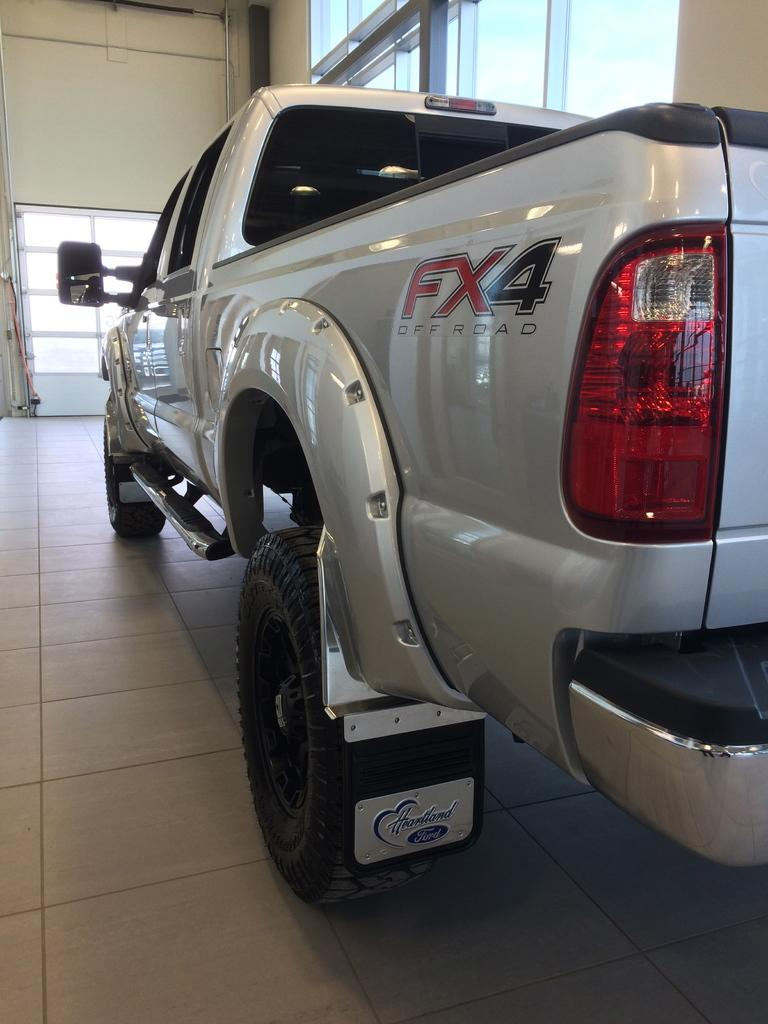What type of object is the main subject in the image? There is a vehicle in the image. What color is the vehicle? The vehicle is white in color. Is there any text or writing on the vehicle? Yes, there is writing on the vehicle. What can be seen on the floor in the image? The floor is visible in the image. What is visible in the background of the image? There is a wall and windows in the background of the image. What flavor of kite can be seen flying in the image? There is no kite present in the image, so it is not possible to determine the flavor of any kite. 